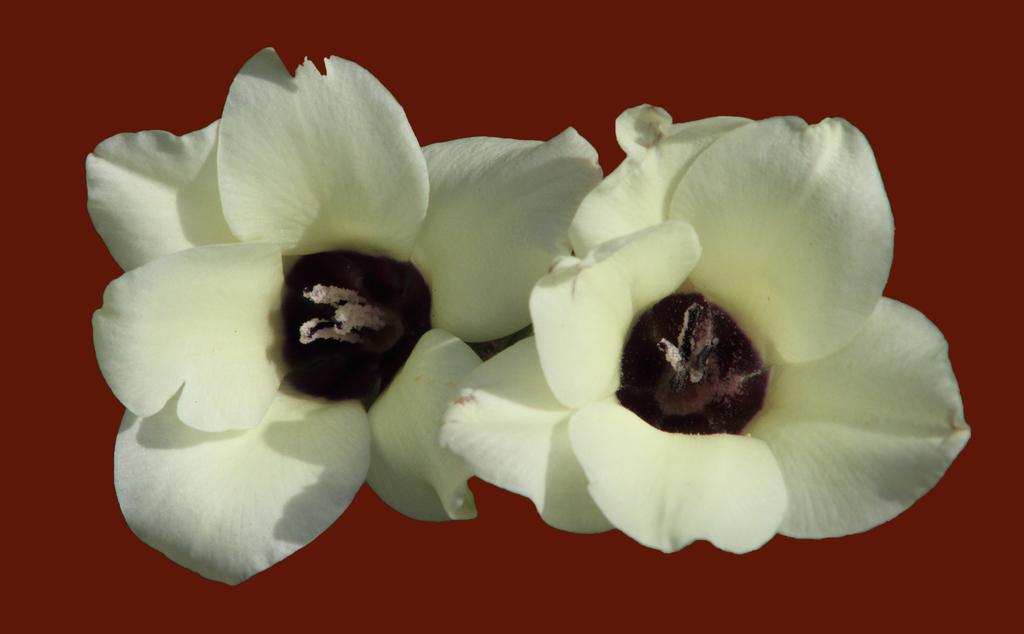Can you describe this image briefly? In this image, we can see flowers on the red background. 